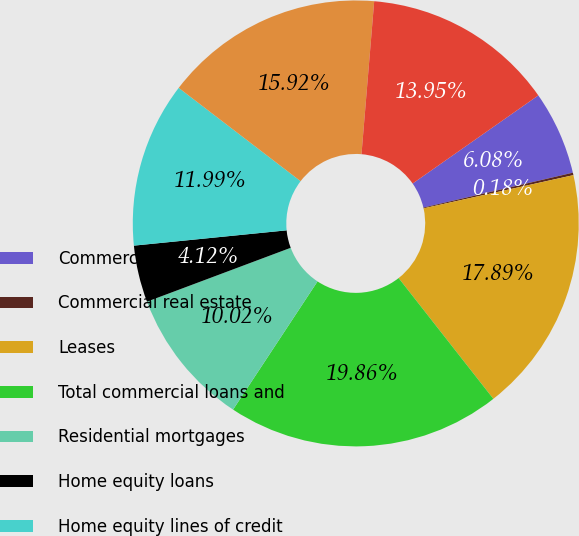<chart> <loc_0><loc_0><loc_500><loc_500><pie_chart><fcel>Commercial<fcel>Commercial real estate<fcel>Leases<fcel>Total commercial loans and<fcel>Residential mortgages<fcel>Home equity loans<fcel>Home equity lines of credit<fcel>Home equity loans serviced by<fcel>Education<nl><fcel>6.08%<fcel>0.18%<fcel>17.89%<fcel>19.86%<fcel>10.02%<fcel>4.12%<fcel>11.99%<fcel>15.92%<fcel>13.95%<nl></chart> 